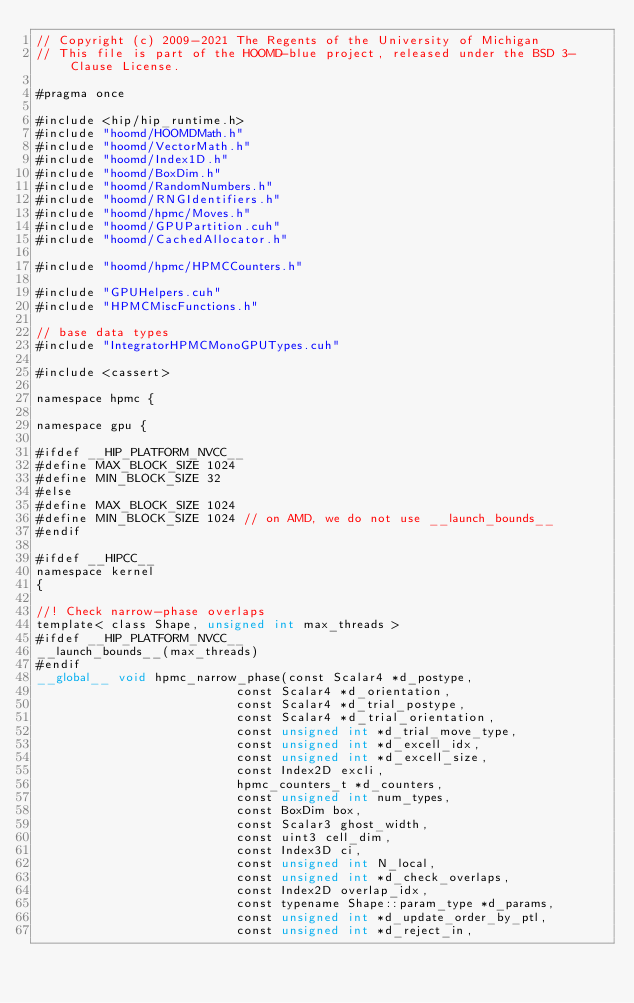<code> <loc_0><loc_0><loc_500><loc_500><_Cuda_>// Copyright (c) 2009-2021 The Regents of the University of Michigan
// This file is part of the HOOMD-blue project, released under the BSD 3-Clause License.

#pragma once

#include <hip/hip_runtime.h>
#include "hoomd/HOOMDMath.h"
#include "hoomd/VectorMath.h"
#include "hoomd/Index1D.h"
#include "hoomd/BoxDim.h"
#include "hoomd/RandomNumbers.h"
#include "hoomd/RNGIdentifiers.h"
#include "hoomd/hpmc/Moves.h"
#include "hoomd/GPUPartition.cuh"
#include "hoomd/CachedAllocator.h"

#include "hoomd/hpmc/HPMCCounters.h"

#include "GPUHelpers.cuh"
#include "HPMCMiscFunctions.h"

// base data types
#include "IntegratorHPMCMonoGPUTypes.cuh"

#include <cassert>

namespace hpmc {

namespace gpu {

#ifdef __HIP_PLATFORM_NVCC__
#define MAX_BLOCK_SIZE 1024
#define MIN_BLOCK_SIZE 32
#else
#define MAX_BLOCK_SIZE 1024
#define MIN_BLOCK_SIZE 1024 // on AMD, we do not use __launch_bounds__
#endif

#ifdef __HIPCC__
namespace kernel
{

//! Check narrow-phase overlaps
template< class Shape, unsigned int max_threads >
#ifdef __HIP_PLATFORM_NVCC__
__launch_bounds__(max_threads)
#endif
__global__ void hpmc_narrow_phase(const Scalar4 *d_postype,
                           const Scalar4 *d_orientation,
                           const Scalar4 *d_trial_postype,
                           const Scalar4 *d_trial_orientation,
                           const unsigned int *d_trial_move_type,
                           const unsigned int *d_excell_idx,
                           const unsigned int *d_excell_size,
                           const Index2D excli,
                           hpmc_counters_t *d_counters,
                           const unsigned int num_types,
                           const BoxDim box,
                           const Scalar3 ghost_width,
                           const uint3 cell_dim,
                           const Index3D ci,
                           const unsigned int N_local,
                           const unsigned int *d_check_overlaps,
                           const Index2D overlap_idx,
                           const typename Shape::param_type *d_params,
                           const unsigned int *d_update_order_by_ptl,
                           const unsigned int *d_reject_in,</code> 